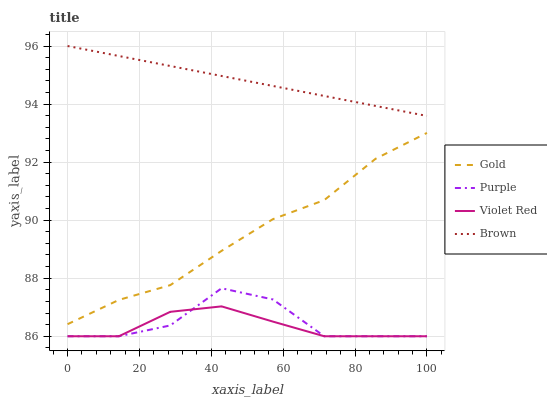Does Brown have the minimum area under the curve?
Answer yes or no. No. Does Violet Red have the maximum area under the curve?
Answer yes or no. No. Is Violet Red the smoothest?
Answer yes or no. No. Is Violet Red the roughest?
Answer yes or no. No. Does Brown have the lowest value?
Answer yes or no. No. Does Violet Red have the highest value?
Answer yes or no. No. Is Violet Red less than Gold?
Answer yes or no. Yes. Is Brown greater than Gold?
Answer yes or no. Yes. Does Violet Red intersect Gold?
Answer yes or no. No. 